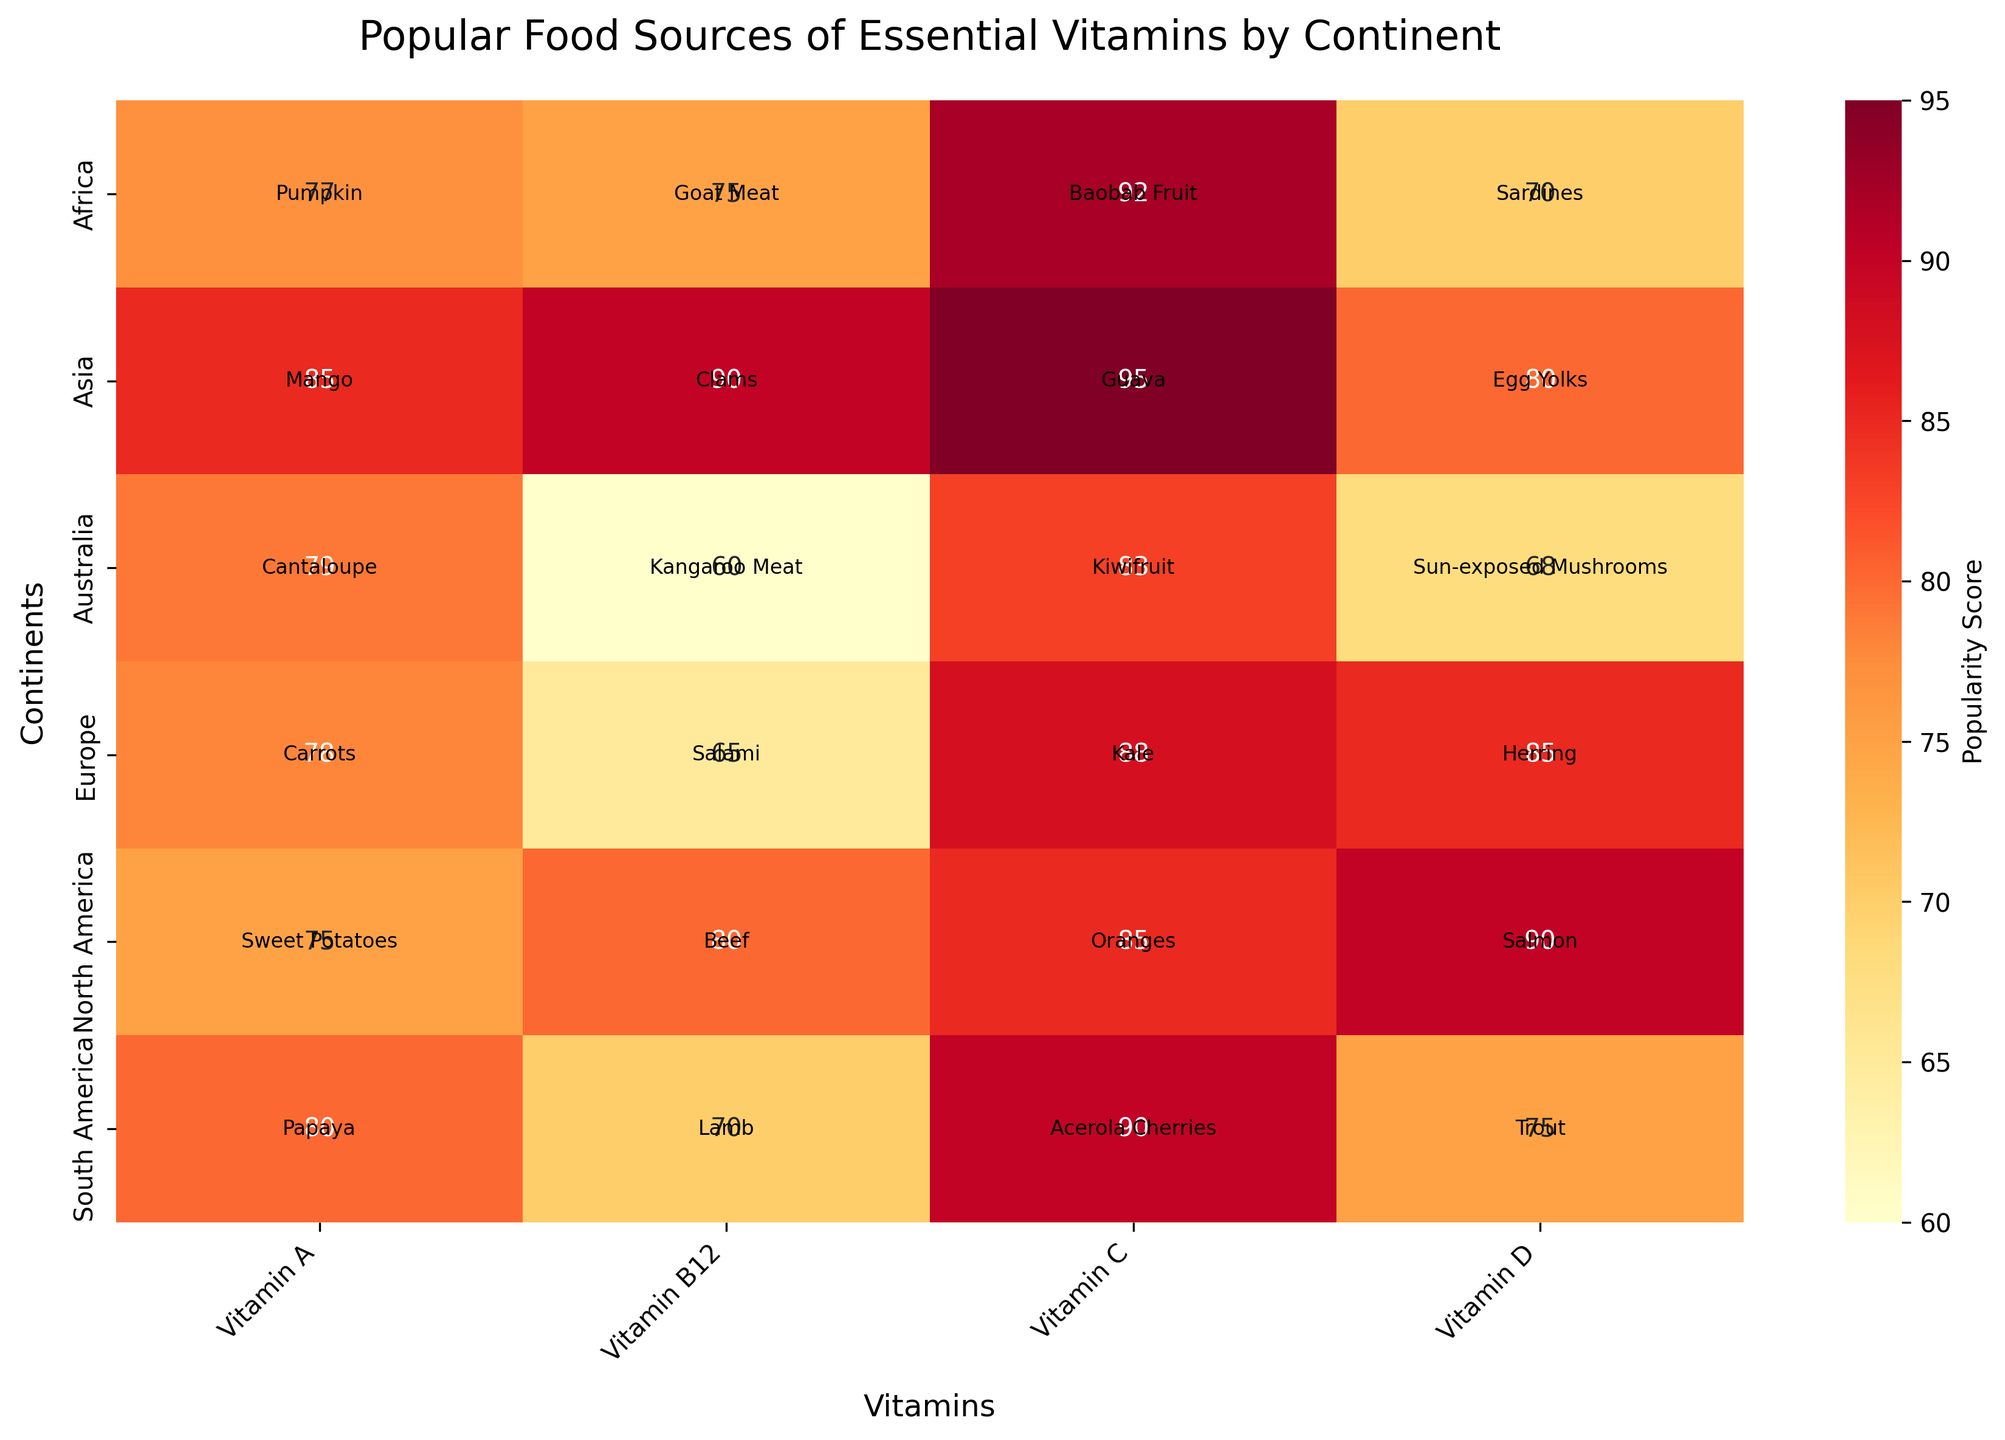What's the title of the heatmap? The title of the heatmap is located at the top of the figure. It provides a summary of the information presented. By looking at the top of the heatmap, you can see the complete title.
Answer: Popular Food Sources of Essential Vitamins by Continent Which continent has the highest popularity score for Vitamin C? To determine this, look along the Vitamin C column and find the highest score in that column. The heatmap shows Africa with a score of 92.
Answer: Africa How many continents are included in the heatmap? Count the number of unique rows along the 'Continent' axis. Each row represents a different continent. There are six rows, corresponding to six continents.
Answer: Six What is the popular food source for Vitamin A in South America? Find the cell where South America intersects with Vitamin A and look at the annotation text within that cell. The annotation notes the food source.
Answer: Papaya What is the difference in popularity scores between the popular Vitamin D food sources in North America and Australia? To find this, locate the Vitamin D scores for North America (Salmon, 90) and Australia (Sun-exposed Mushrooms, 68). Subtract the smaller score from the larger one: 90 - 68.
Answer: 22 Which vitamin has the lowest popularity score in Europe? Compare the popularity scores for all vitamins in the Europe row. The lowest score is for Vitamin B12, which is 65.
Answer: Vitamin B12 What is the common characteristic of the heatmap colors used? The colors range from light yellow to dark red, indicating that the intensity of the score increases from light to dark. Lighter colors represent lower scores, and darker colors represent higher scores.
Answer: Intensity increases with score Which vitamin in Asia has the highest popularity score, and what is the corresponding food source? Check the popularity scores for each vitamin in the Asia row. The highest score is for Vitamin C, which is 95. The corresponding food source for Vitamin C is Guava.
Answer: Vitamin C, Guava Between Africa and Europe, which continent has a higher average popularity score for all vitamins combined, and what is the average score for each? Calculate the average scores for both continents by summing the scores and dividing by the number of vitamins (4 per continent). Africa's scores: 92, 70, 77, 75 (average: 78.5). Europe's scores: 88, 85, 78, 65 (average: 79).
Answer: Europe, 79 Which continent has the lowest popularity score for any vitamin, and what is the score? Look for the lowest value across all the cells in the heatmap. The lowest score is 60 for Vitamin B12 in Australia.
Answer: Australia, 60 